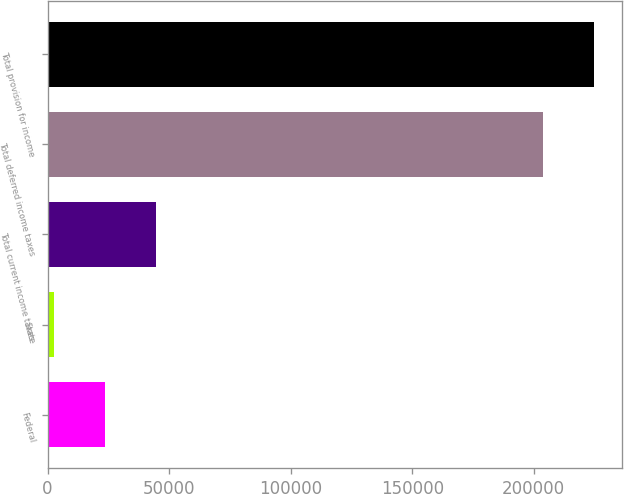Convert chart. <chart><loc_0><loc_0><loc_500><loc_500><bar_chart><fcel>Federal<fcel>State<fcel>Total current income taxes<fcel>Total deferred income taxes<fcel>Total provision for income<nl><fcel>23444.7<fcel>2449<fcel>44440.4<fcel>203871<fcel>224867<nl></chart> 